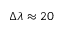<formula> <loc_0><loc_0><loc_500><loc_500>\Delta \lambda \approx 2 0</formula> 